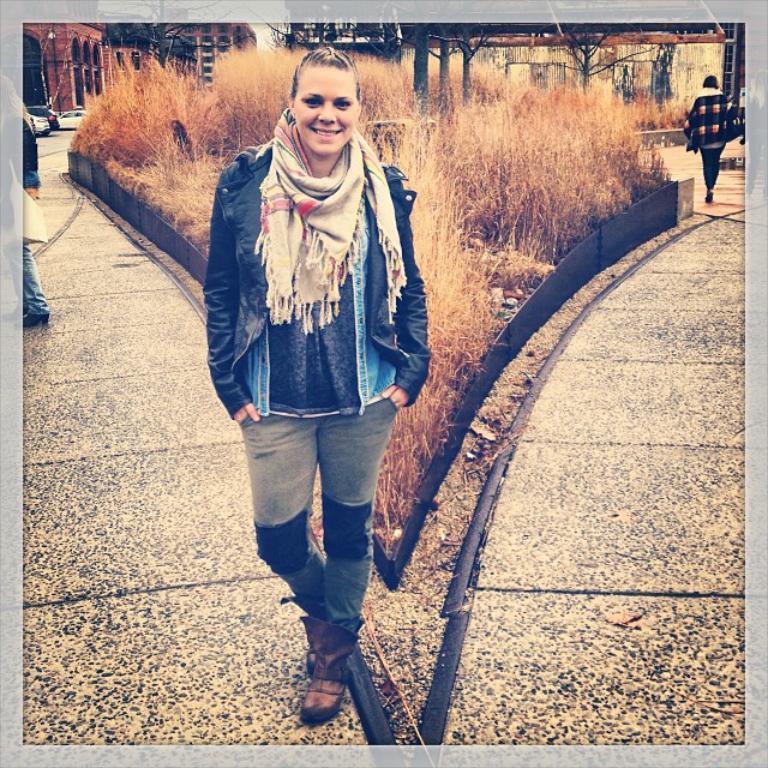How would you summarize this image in a sentence or two? In this image in the front there is a woman standing and smiling. In the center there is dry grass and in the background there are buildings, cars and there are persons. 